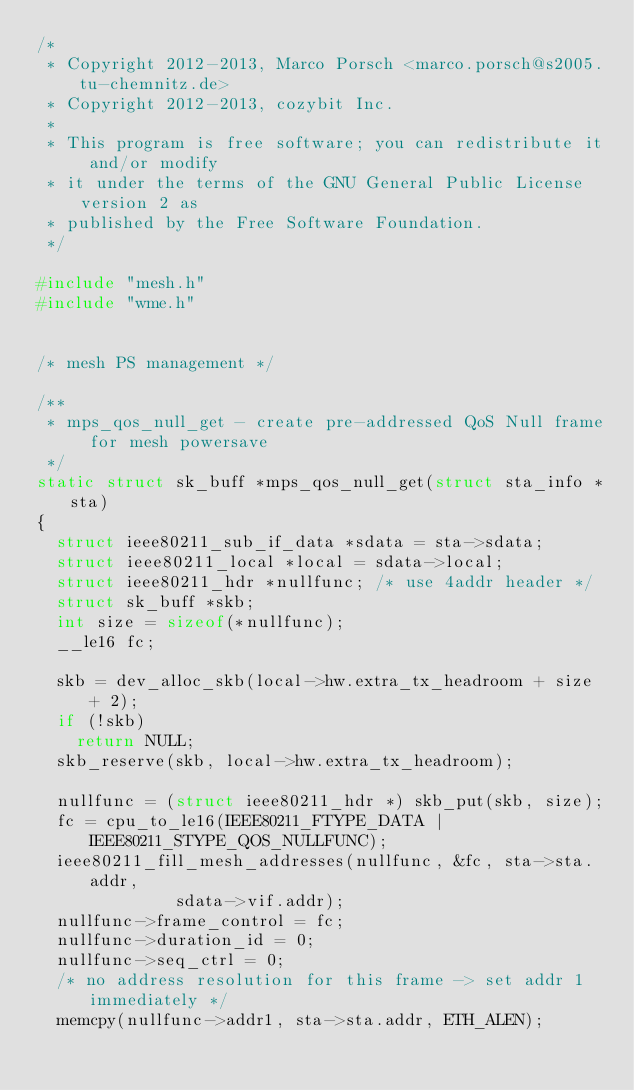Convert code to text. <code><loc_0><loc_0><loc_500><loc_500><_C_>/*
 * Copyright 2012-2013, Marco Porsch <marco.porsch@s2005.tu-chemnitz.de>
 * Copyright 2012-2013, cozybit Inc.
 *
 * This program is free software; you can redistribute it and/or modify
 * it under the terms of the GNU General Public License version 2 as
 * published by the Free Software Foundation.
 */

#include "mesh.h"
#include "wme.h"


/* mesh PS management */

/**
 * mps_qos_null_get - create pre-addressed QoS Null frame for mesh powersave
 */
static struct sk_buff *mps_qos_null_get(struct sta_info *sta)
{
	struct ieee80211_sub_if_data *sdata = sta->sdata;
	struct ieee80211_local *local = sdata->local;
	struct ieee80211_hdr *nullfunc; /* use 4addr header */
	struct sk_buff *skb;
	int size = sizeof(*nullfunc);
	__le16 fc;

	skb = dev_alloc_skb(local->hw.extra_tx_headroom + size + 2);
	if (!skb)
		return NULL;
	skb_reserve(skb, local->hw.extra_tx_headroom);

	nullfunc = (struct ieee80211_hdr *) skb_put(skb, size);
	fc = cpu_to_le16(IEEE80211_FTYPE_DATA | IEEE80211_STYPE_QOS_NULLFUNC);
	ieee80211_fill_mesh_addresses(nullfunc, &fc, sta->sta.addr,
				      sdata->vif.addr);
	nullfunc->frame_control = fc;
	nullfunc->duration_id = 0;
	nullfunc->seq_ctrl = 0;
	/* no address resolution for this frame -> set addr 1 immediately */
	memcpy(nullfunc->addr1, sta->sta.addr, ETH_ALEN);</code> 